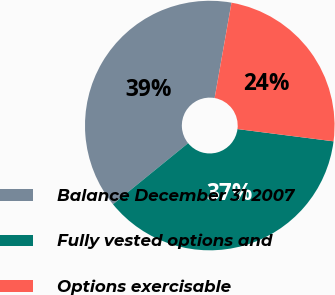<chart> <loc_0><loc_0><loc_500><loc_500><pie_chart><fcel>Balance December 31 2007<fcel>Fully vested options and<fcel>Options exercisable<nl><fcel>38.65%<fcel>37.11%<fcel>24.23%<nl></chart> 